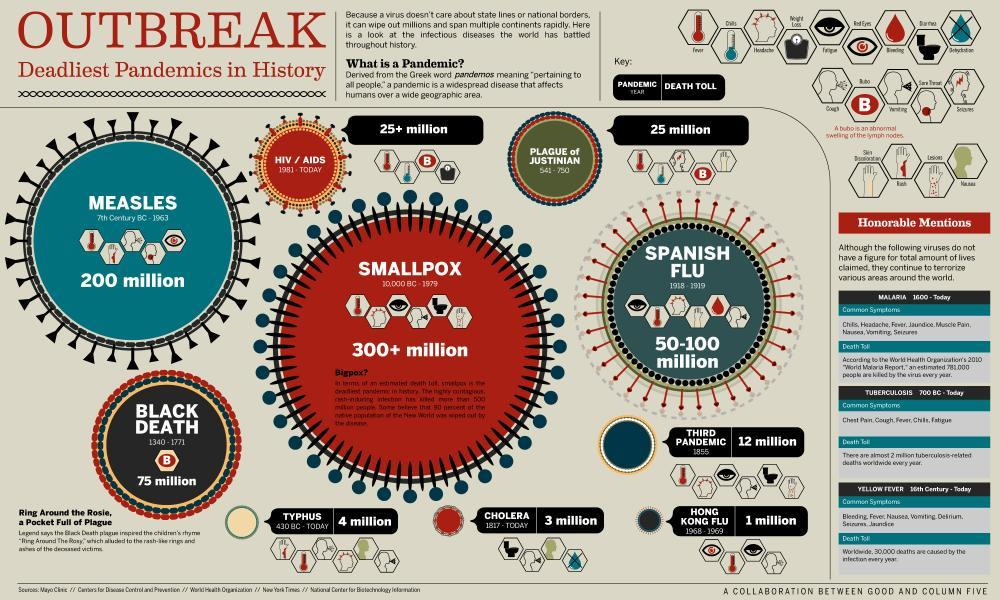During which time period, the Spanish flu pandemic happened?
Answer the question with a short phrase. 1918 - 1919 When did the third plague pandemic begin? 1855 How many people were killed by the Hong Kong Flu? 1 million How many people were affected by smallpox disease? 300+ million How many people were affected by measles disease? 200 million 